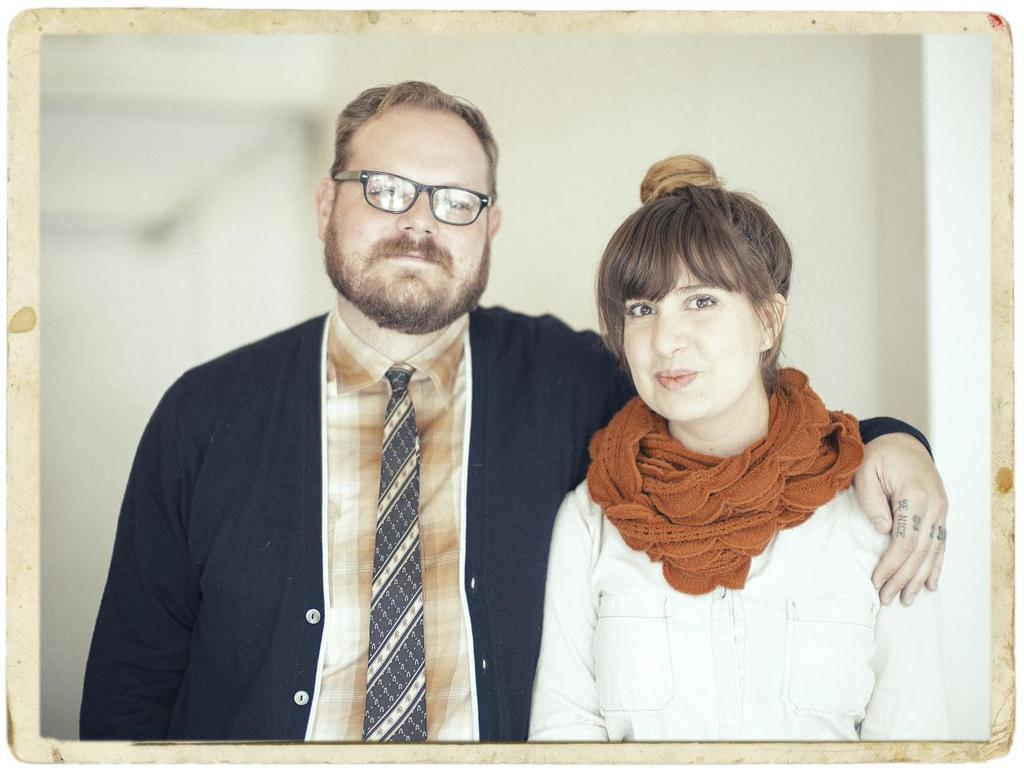What is the main subject of the image? There is a photograph in the image. Who or what can be seen in the photograph? The photograph contains a man and a woman. What is the man wearing in the photograph? The man is wearing a black suit, a tie, and a shirt. What is the woman wearing in the photograph? The woman is wearing a white dress. What type of plants can be seen growing on the throne in the image? There is no throne or plants present in the image; it features a photograph of a man and a woman. 